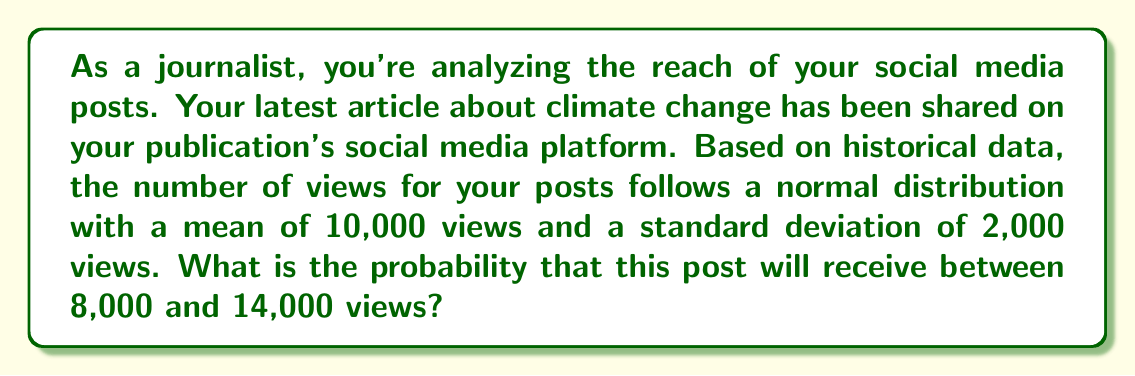Can you answer this question? To solve this problem, we need to use the properties of the normal distribution and the concept of z-scores. Let's break it down step-by-step:

1. Given information:
   - The distribution is normal
   - Mean (μ) = 10,000 views
   - Standard deviation (σ) = 2,000 views
   - We want to find P(8,000 < X < 14,000)

2. Convert the view counts to z-scores:
   For 8,000 views: $z_1 = \frac{8,000 - 10,000}{2,000} = -1$
   For 14,000 views: $z_2 = \frac{14,000 - 10,000}{2,000} = 2$

3. The problem now becomes finding P(-1 < Z < 2) for a standard normal distribution.

4. Using a standard normal distribution table or calculator:
   P(Z < -1) ≈ 0.1587
   P(Z < 2) ≈ 0.9772

5. The probability we're looking for is the difference between these two values:
   P(-1 < Z < 2) = P(Z < 2) - P(Z < -1)
                 ≈ 0.9772 - 0.1587
                 ≈ 0.8185

6. Convert to a percentage:
   0.8185 * 100% ≈ 81.85%

Therefore, the probability that the post will receive between 8,000 and 14,000 views is approximately 81.85%.
Answer: The probability that the post will receive between 8,000 and 14,000 views is approximately 81.85%. 